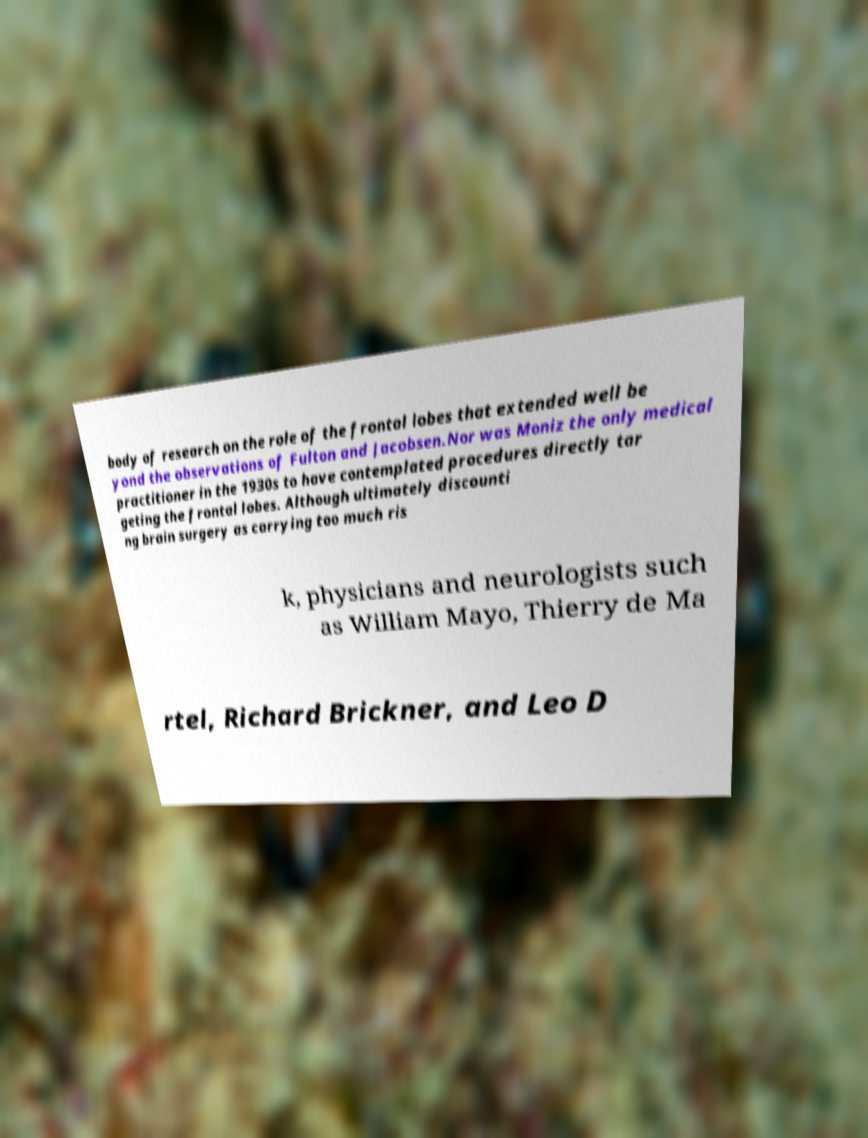Could you assist in decoding the text presented in this image and type it out clearly? body of research on the role of the frontal lobes that extended well be yond the observations of Fulton and Jacobsen.Nor was Moniz the only medical practitioner in the 1930s to have contemplated procedures directly tar geting the frontal lobes. Although ultimately discounti ng brain surgery as carrying too much ris k, physicians and neurologists such as William Mayo, Thierry de Ma rtel, Richard Brickner, and Leo D 